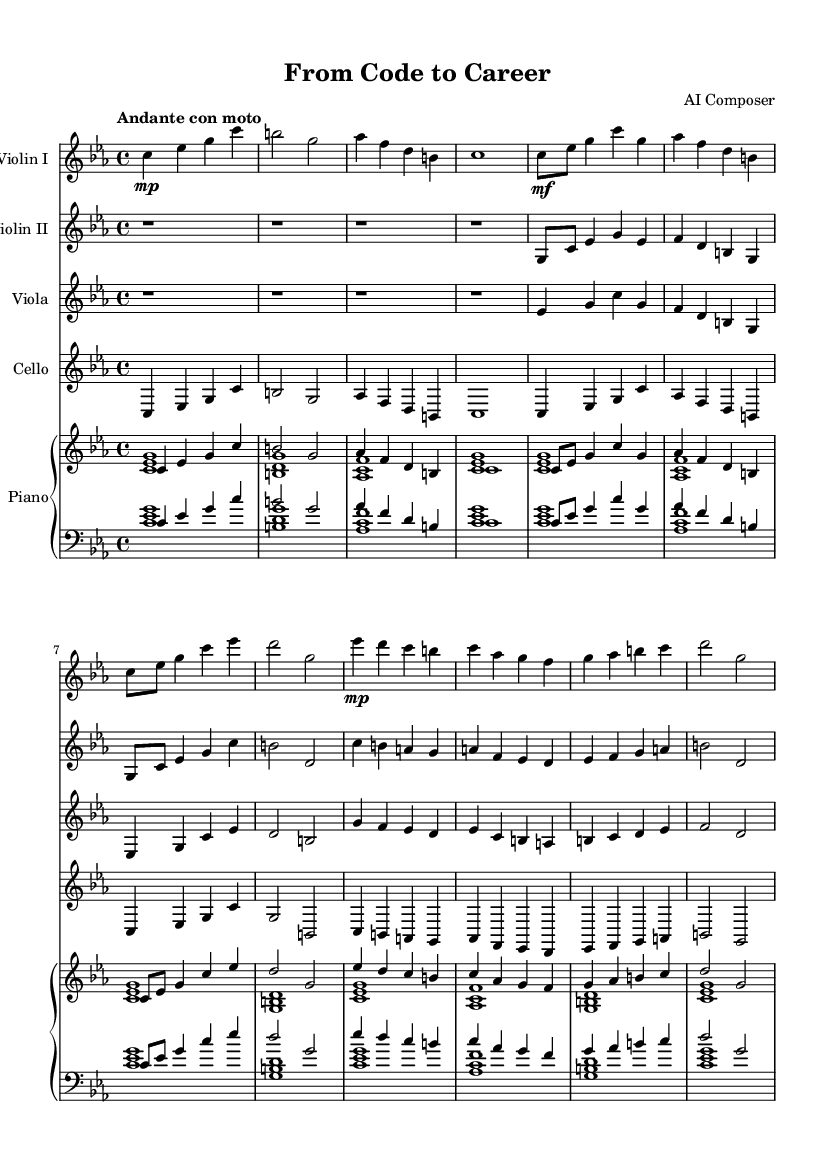What is the key signature of this music? The key signature is indicated by the number of sharps or flats at the beginning of the staff. This piece is in C minor, which has three flats (B flat, E flat, and A flat).
Answer: C minor What is the time signature of this piece? The time signature is represented by the two numbers at the beginning of the staff, indicating how many beats are in each measure and what type of note gets one beat. In this case, it is 4/4, meaning four beats per measure with the quarter note getting one beat.
Answer: 4/4 What is the tempo marking for this symphony? The tempo marking is generally placed above the staff at the beginning of the piece and describes the speed of the music. Here, the marking is "Andante con moto," indicating a moderately slow tempo with some movement.
Answer: Andante con moto Which instrument plays the introduction? Looking at the first section of the music, the introduction is shown in the violin I part, where it starts with the notes c, es, g, and c.
Answer: Violin I How many different themes are represented in this piece? By examining the structure of the music, it consists of two distinct themes: Theme A represents Student Life and Theme B represents Learning and Growth. Each theme is clearly marked in the score.
Answer: Two What dynamics are indicated for the violin I during Theme A? The dynamics for the violin I part during Theme A are indicated by the markings such as "mf" (mezzo-forte) and "mp" (mezzo-piano). This shows variations in volume and expression throughout the theme.
Answer: mf, mp 